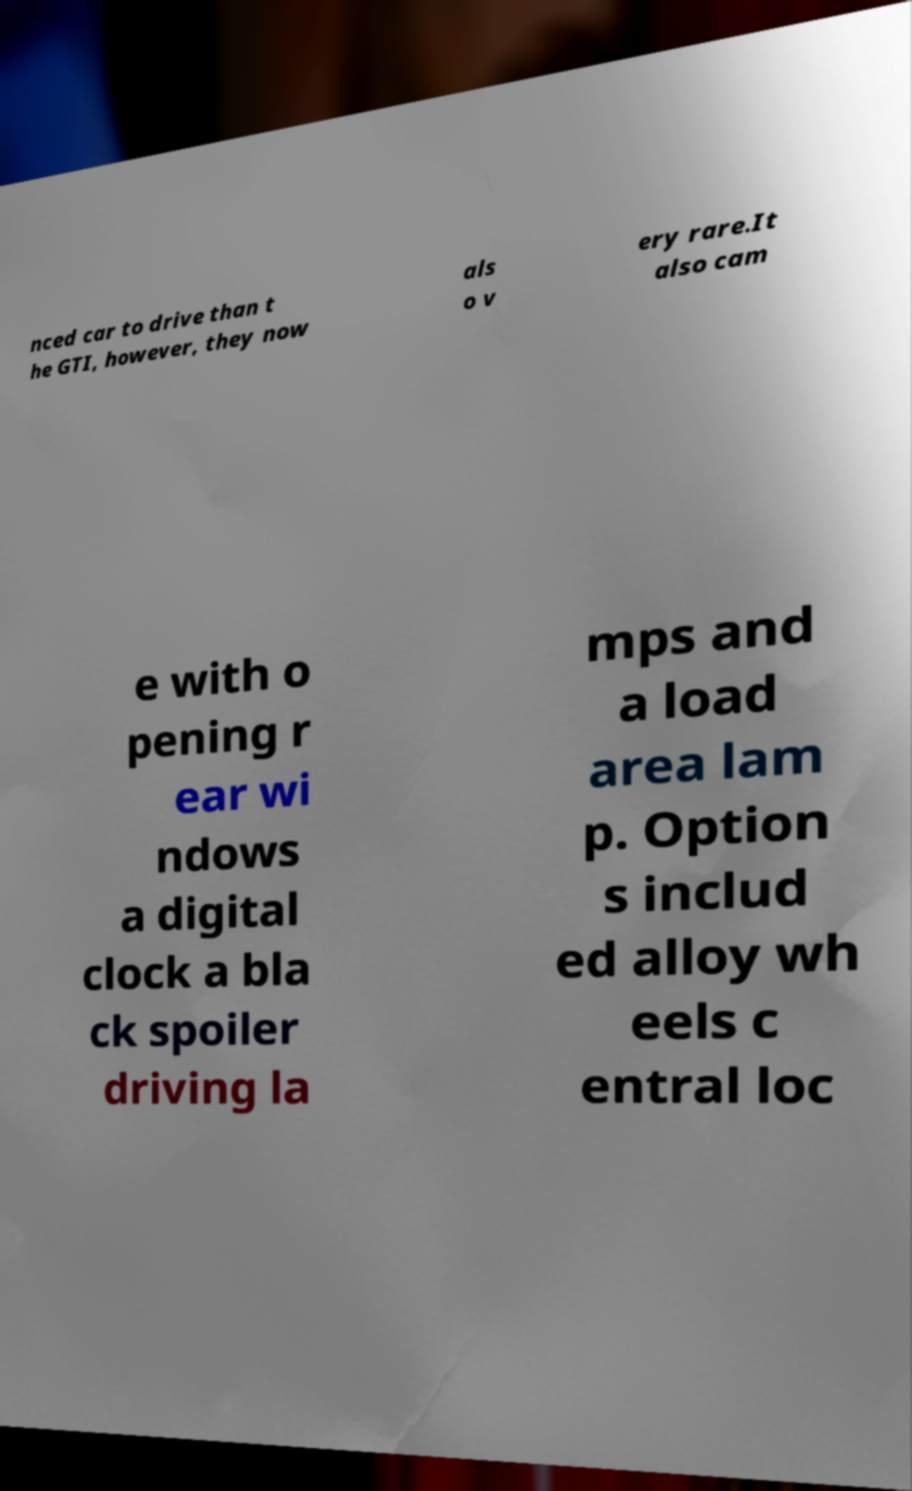There's text embedded in this image that I need extracted. Can you transcribe it verbatim? nced car to drive than t he GTI, however, they now als o v ery rare.It also cam e with o pening r ear wi ndows a digital clock a bla ck spoiler driving la mps and a load area lam p. Option s includ ed alloy wh eels c entral loc 